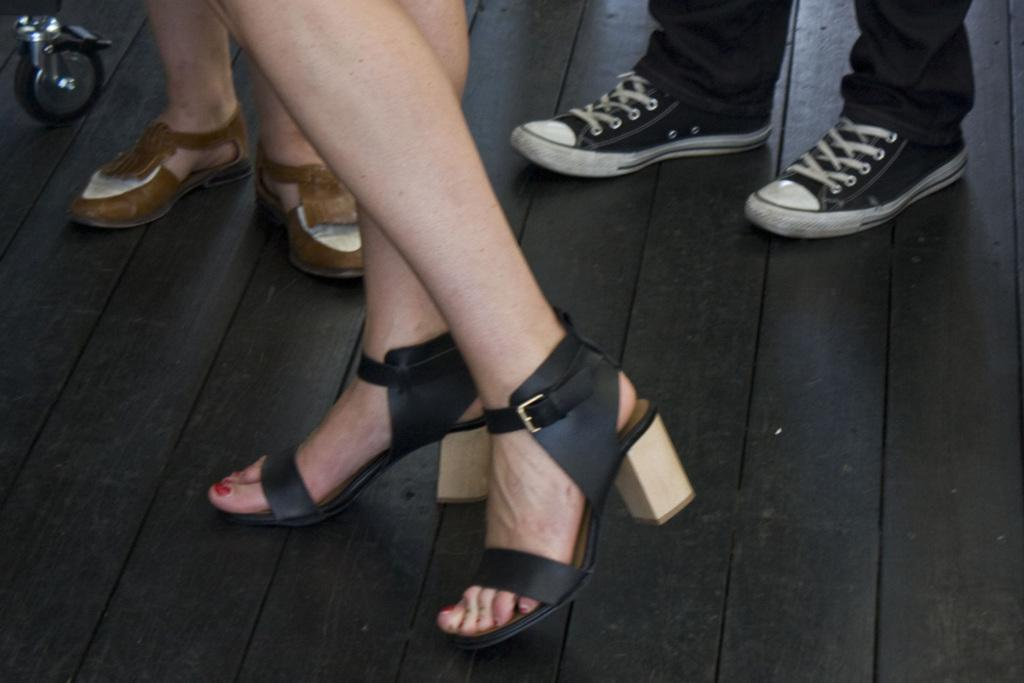What body parts are visible in the image? There are people's legs visible in the image. What type of clothing is on the legs? The legs have footwear on them. What material is the floor made of? The floor is made of wood. What object with a circular shape can be seen in the image? There is a wheel in the image. How many brothers are present in the image? There is no information about brothers in the image, as it only shows people's legs and a wheel. 